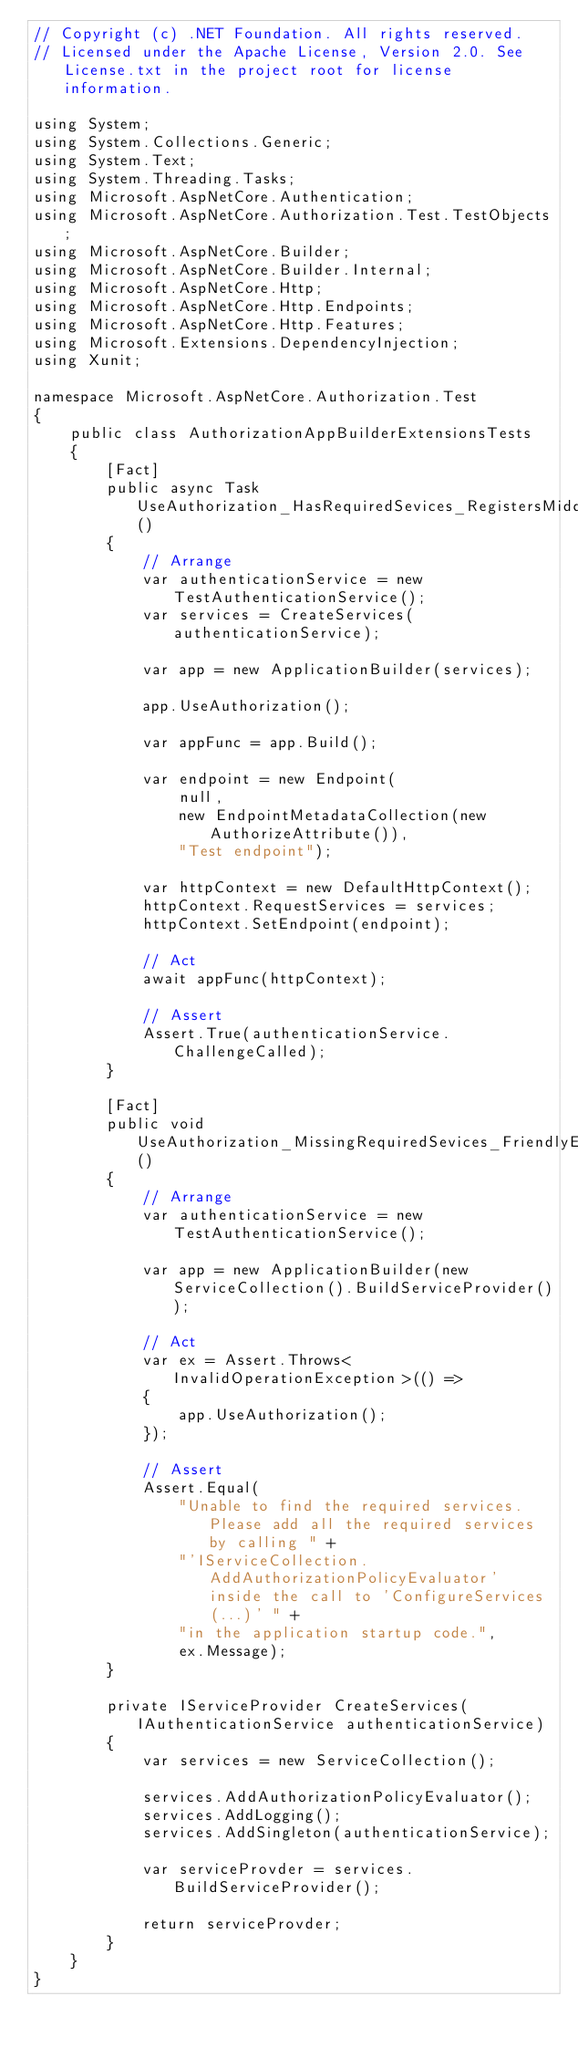<code> <loc_0><loc_0><loc_500><loc_500><_C#_>// Copyright (c) .NET Foundation. All rights reserved.
// Licensed under the Apache License, Version 2.0. See License.txt in the project root for license information.

using System;
using System.Collections.Generic;
using System.Text;
using System.Threading.Tasks;
using Microsoft.AspNetCore.Authentication;
using Microsoft.AspNetCore.Authorization.Test.TestObjects;
using Microsoft.AspNetCore.Builder;
using Microsoft.AspNetCore.Builder.Internal;
using Microsoft.AspNetCore.Http;
using Microsoft.AspNetCore.Http.Endpoints;
using Microsoft.AspNetCore.Http.Features;
using Microsoft.Extensions.DependencyInjection;
using Xunit;

namespace Microsoft.AspNetCore.Authorization.Test
{
    public class AuthorizationAppBuilderExtensionsTests
    {
        [Fact]
        public async Task UseAuthorization_HasRequiredSevices_RegistersMiddleware()
        {
            // Arrange
            var authenticationService = new TestAuthenticationService();
            var services = CreateServices(authenticationService);

            var app = new ApplicationBuilder(services);

            app.UseAuthorization();

            var appFunc = app.Build();

            var endpoint = new Endpoint(
                null,
                new EndpointMetadataCollection(new AuthorizeAttribute()),
                "Test endpoint");

            var httpContext = new DefaultHttpContext();
            httpContext.RequestServices = services;
            httpContext.SetEndpoint(endpoint);

            // Act
            await appFunc(httpContext);

            // Assert
            Assert.True(authenticationService.ChallengeCalled);
        }

        [Fact]
        public void UseAuthorization_MissingRequiredSevices_FriendlyErrorMessage()
        {
            // Arrange
            var authenticationService = new TestAuthenticationService();
            
            var app = new ApplicationBuilder(new ServiceCollection().BuildServiceProvider());

            // Act
            var ex = Assert.Throws<InvalidOperationException>(() =>
            {
                app.UseAuthorization();
            });

            // Assert
            Assert.Equal(
                "Unable to find the required services. Please add all the required services by calling " +
                "'IServiceCollection.AddAuthorizationPolicyEvaluator' inside the call to 'ConfigureServices(...)' " +
                "in the application startup code.",
                ex.Message);
        }

        private IServiceProvider CreateServices(IAuthenticationService authenticationService)
        {
            var services = new ServiceCollection();

            services.AddAuthorizationPolicyEvaluator();
            services.AddLogging();
            services.AddSingleton(authenticationService);

            var serviceProvder = services.BuildServiceProvider();

            return serviceProvder;
        }
    }
}
</code> 